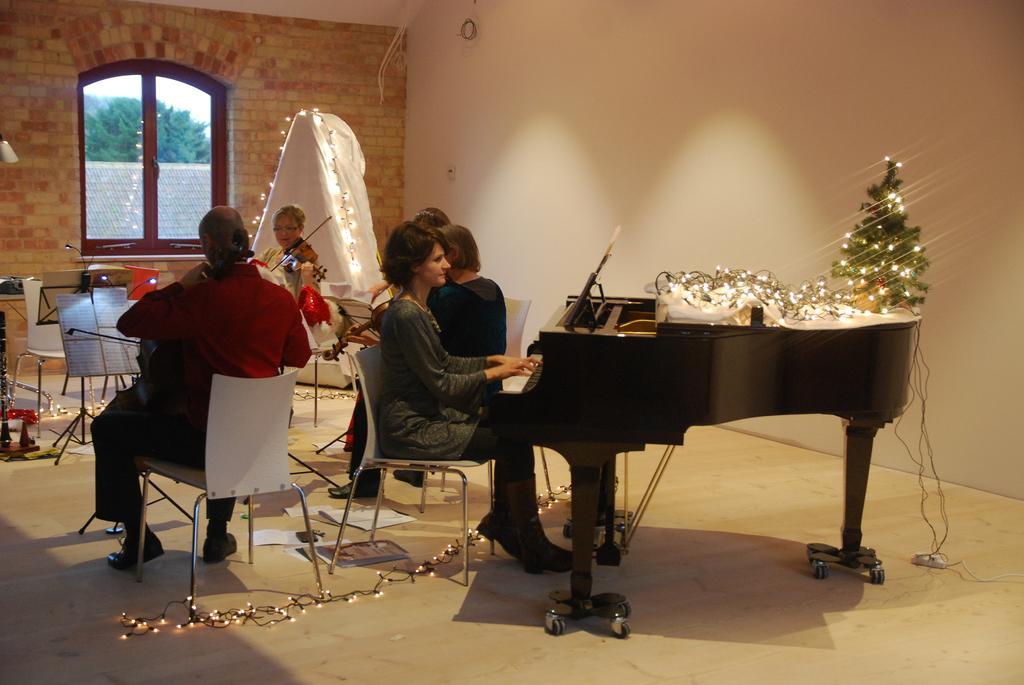In one or two sentences, can you explain what this image depicts? In this image, In the right side there is a piano which is in black color, There is a woman sitting on a chair and she is playing the piano, In the left side there is a man sitting and holding a music instrument, in the background there are some people sitting and holding some music instruments, In the background there is a white color wall, In the left side there is a yellow color and a glass window which is in brown color. 